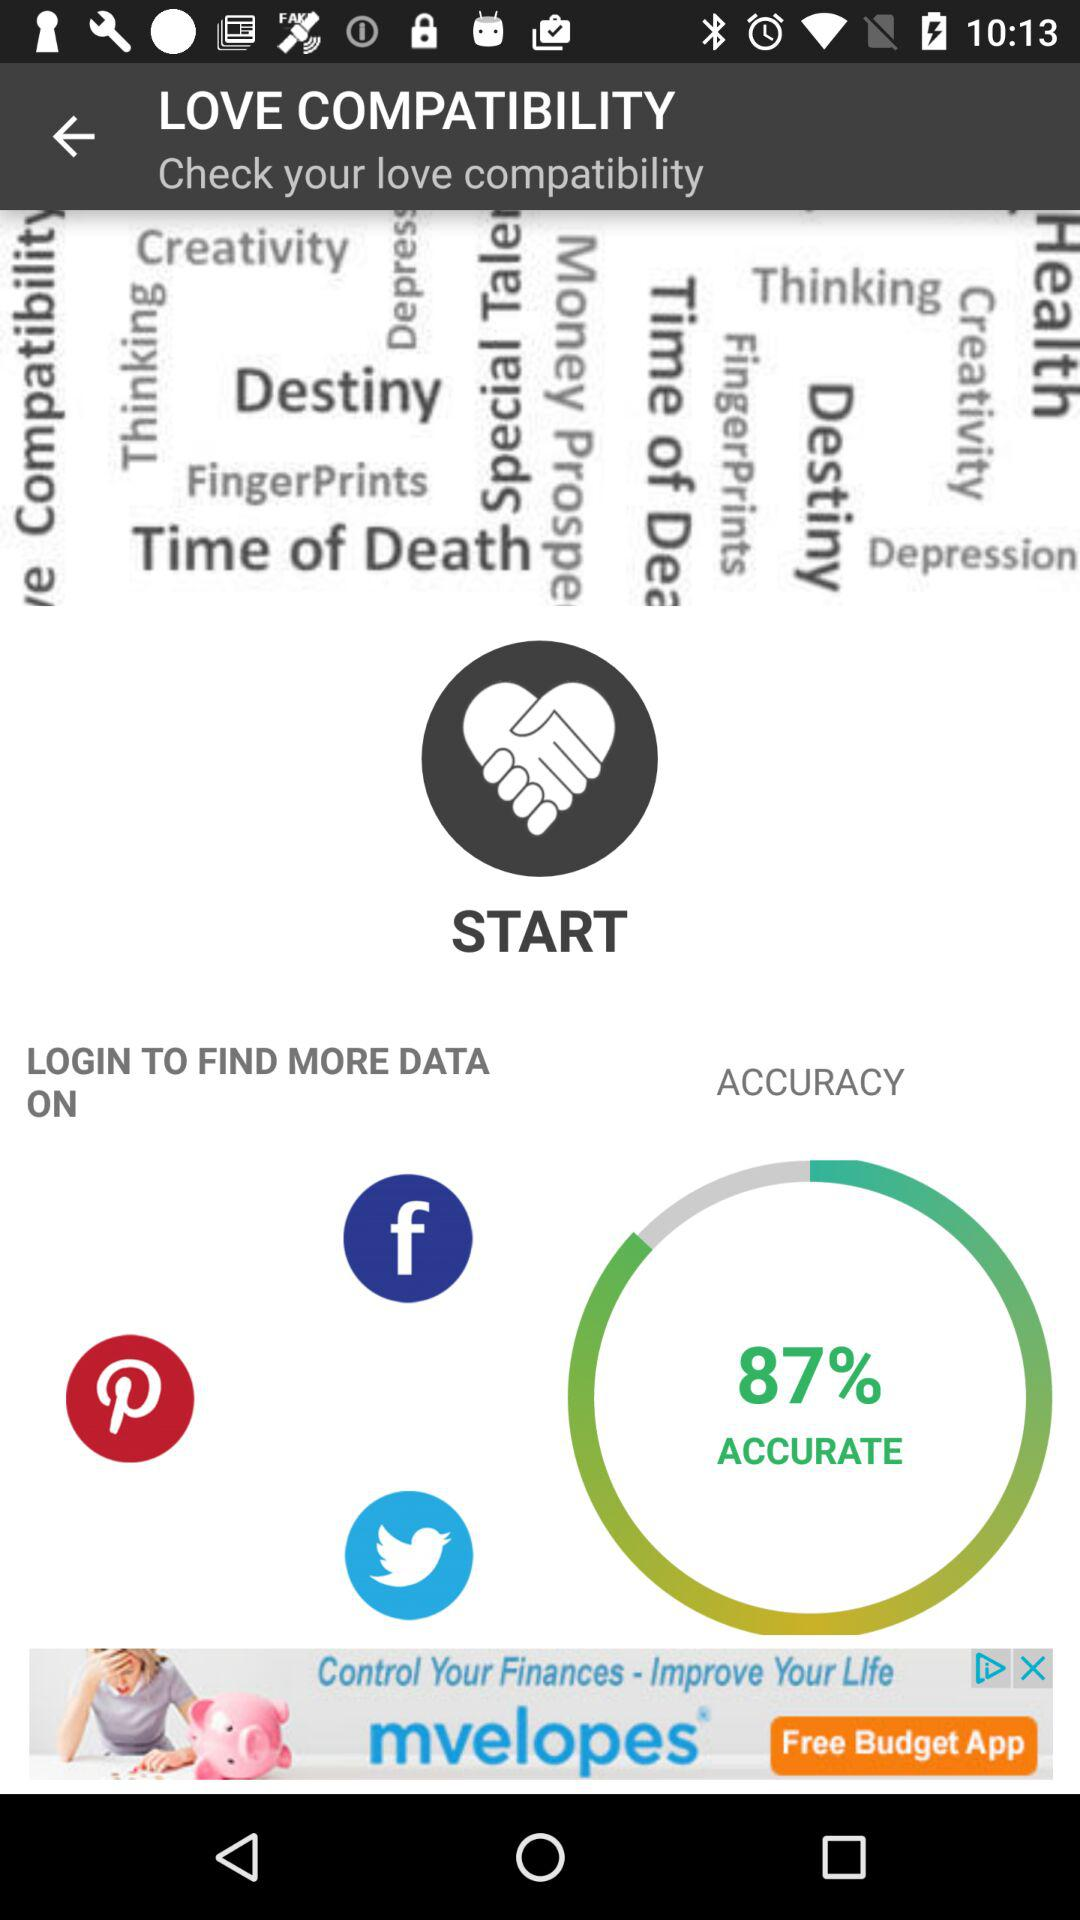What are the login options available? The login options are "Facebook", "Pinterest", and "Twitter". 